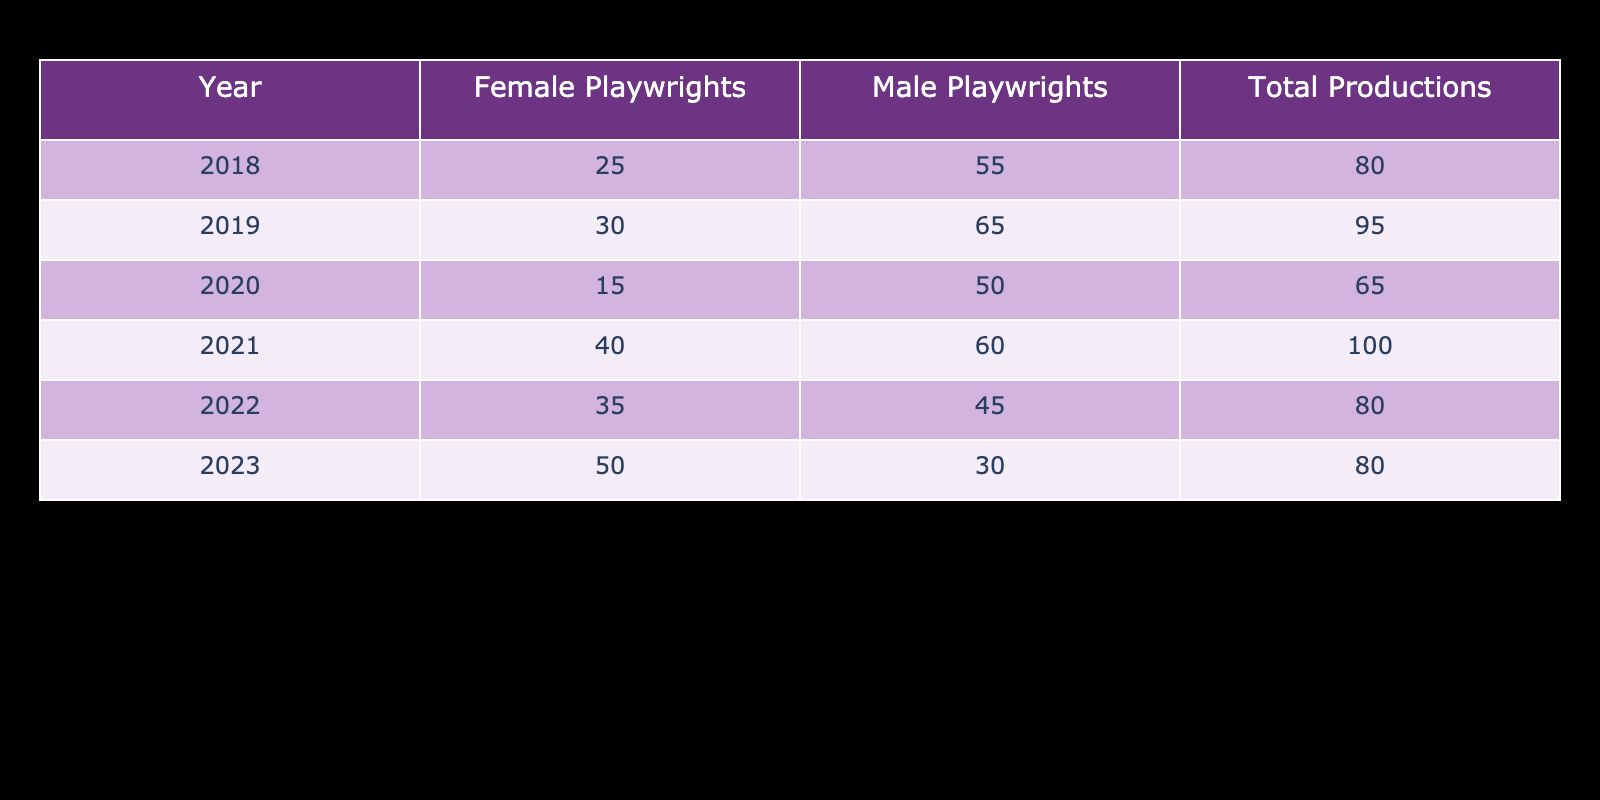What year had the highest number of productions by female playwrights? In the table, we can see the values for female playwrights by year. The numbers are 25, 30, 15, 40, 35, and 50 for the years 2018 to 2023, respectively. The highest value is 50 in 2023.
Answer: 2023 What was the total number of productions in 2019? Referring to the table, in the year 2019, the total productions are listed as 95.
Answer: 95 Which gender had more productions in the year 2022? In 2022, there were 35 productions by female playwrights and 45 by male playwrights. Since 45 is greater than 35, male playwrights had more productions in that year.
Answer: Male playwrights What is the average number of productions by male playwrights from 2018 to 2023? We add the values for male playwrights from each year: 55 + 65 + 50 + 60 + 45 + 30 = 305. There are 6 years, so we divide this sum by 6: 305 / 6 = 50.833. The average is approximately 50.83.
Answer: 50.83 Did the number of productions by female playwrights increase every year? From the table, we observe the values for female playwrights: 25, 30, 15, 40, 35, 50. The value decreased from 2019 to 2020 (30 to 15). Therefore, the productions did not increase every year.
Answer: No What was the difference in total productions between male and female playwrights in 2021? In 2021, the total productions were 100, with 60 by male playwrights and 40 by female playwrights. The difference is 60 - 40 = 20, meaning male playwrights had 20 more productions than female playwrights in 2021.
Answer: 20 Which year had the lowest total number of productions and what was that number? By looking at the total productions column, we see the numbers are 80, 95, 65, 100, 80, and 80 for the years 2018 to 2023. The lowest number is 65 in 2020.
Answer: 2020, 65 What percentage of total productions in 2020 were by male playwrights? In 2020, the total productions were 65, and male playwrights had 50 productions. To find the percentage, we calculate (50 / 65) * 100, which equals approximately 76.92%.
Answer: 76.92% 